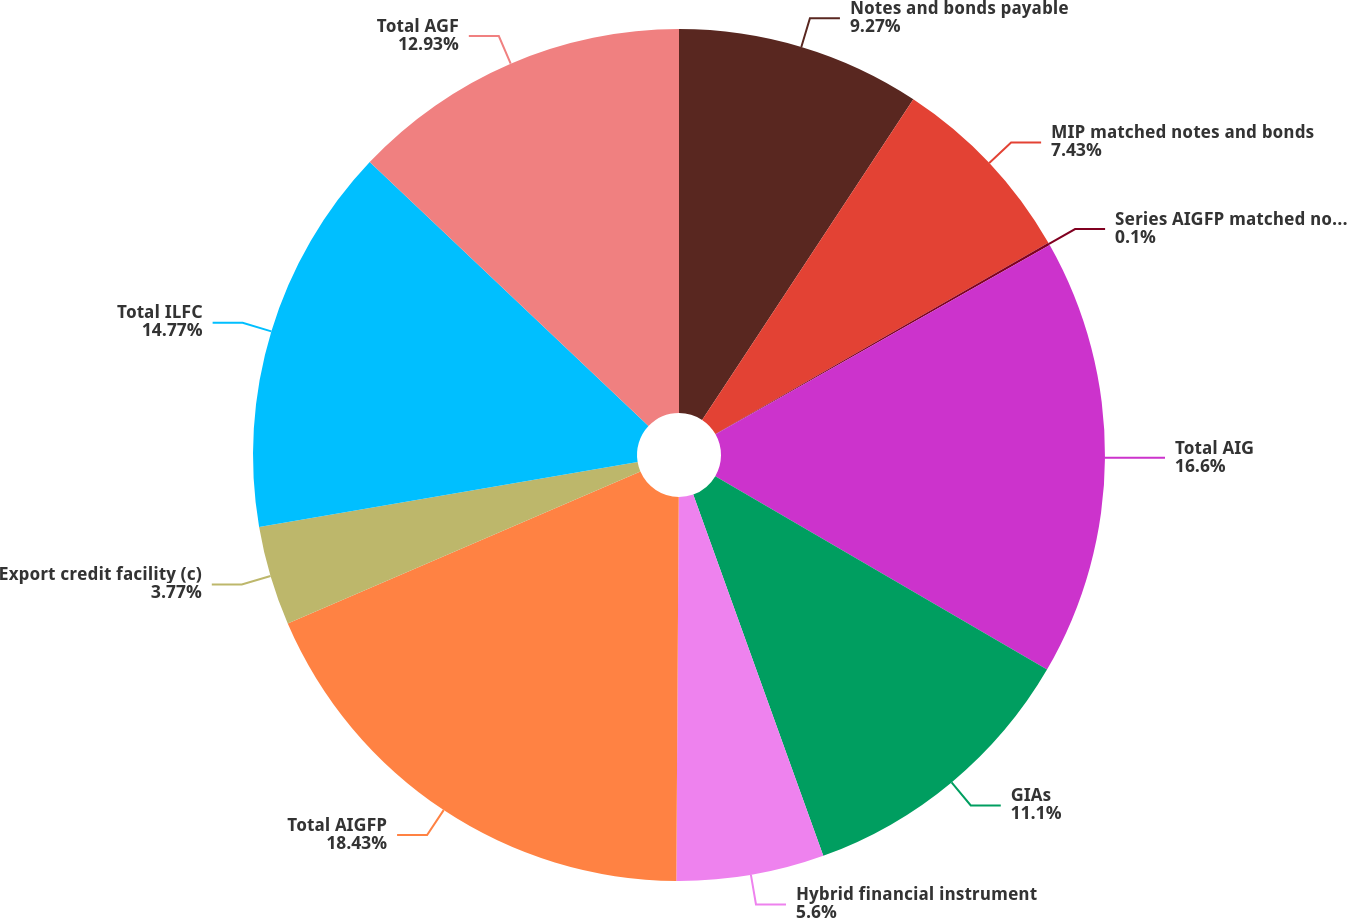<chart> <loc_0><loc_0><loc_500><loc_500><pie_chart><fcel>Notes and bonds payable<fcel>MIP matched notes and bonds<fcel>Series AIGFP matched notes and<fcel>Total AIG<fcel>GIAs<fcel>Hybrid financial instrument<fcel>Total AIGFP<fcel>Export credit facility (c)<fcel>Total ILFC<fcel>Total AGF<nl><fcel>9.27%<fcel>7.43%<fcel>0.1%<fcel>16.6%<fcel>11.1%<fcel>5.6%<fcel>18.43%<fcel>3.77%<fcel>14.77%<fcel>12.93%<nl></chart> 